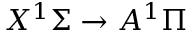Convert formula to latex. <formula><loc_0><loc_0><loc_500><loc_500>X ^ { 1 } \Sigma \rightarrow A ^ { 1 } \Pi</formula> 